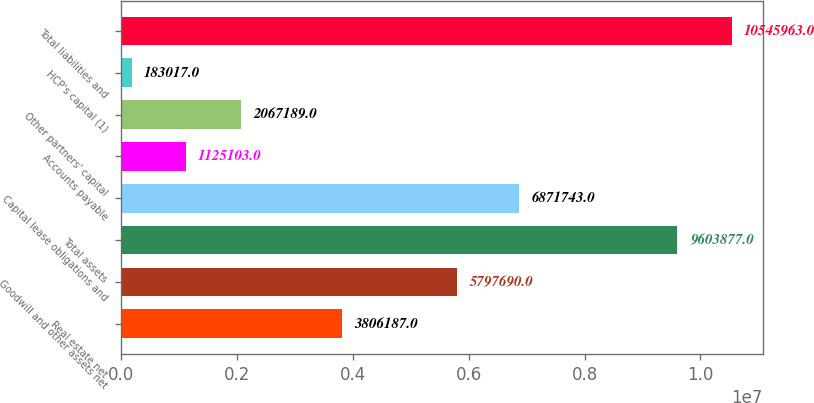Convert chart. <chart><loc_0><loc_0><loc_500><loc_500><bar_chart><fcel>Real estate net<fcel>Goodwill and other assets net<fcel>Total assets<fcel>Capital lease obligations and<fcel>Accounts payable<fcel>Other partners' capital<fcel>HCP's capital (1)<fcel>Total liabilities and<nl><fcel>3.80619e+06<fcel>5.79769e+06<fcel>9.60388e+06<fcel>6.87174e+06<fcel>1.1251e+06<fcel>2.06719e+06<fcel>183017<fcel>1.0546e+07<nl></chart> 